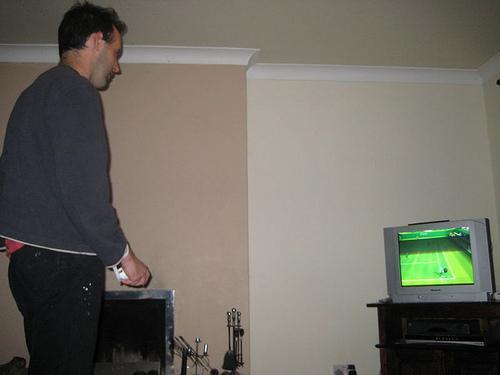How many people are there?
Give a very brief answer. 1. 